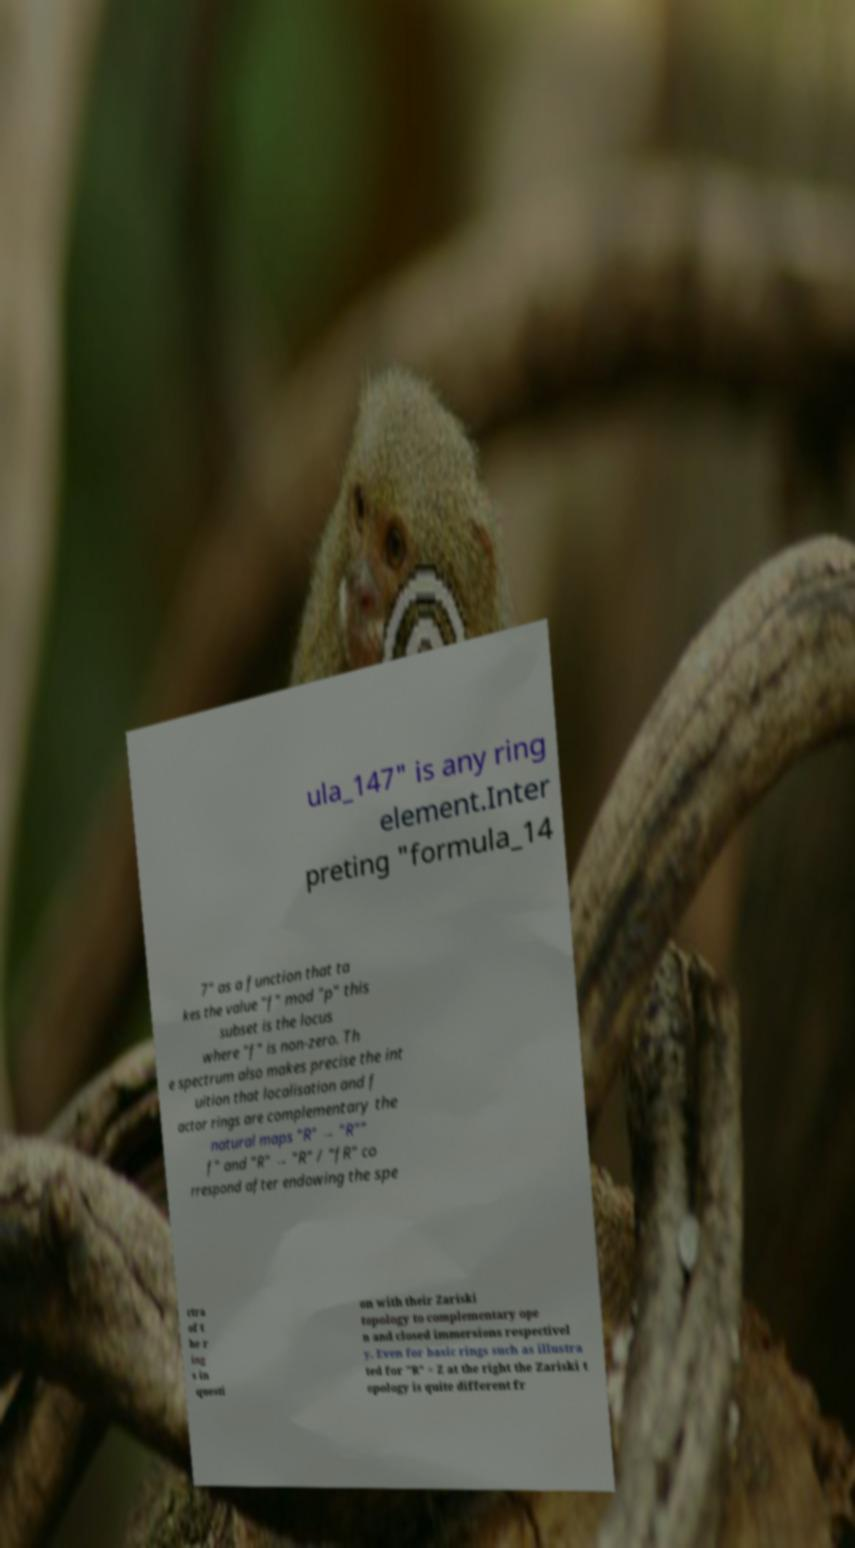Can you read and provide the text displayed in the image?This photo seems to have some interesting text. Can you extract and type it out for me? ula_147" is any ring element.Inter preting "formula_14 7" as a function that ta kes the value "f" mod "p" this subset is the locus where "f" is non-zero. Th e spectrum also makes precise the int uition that localisation and f actor rings are complementary the natural maps "R" → "R"" f" and "R" → "R" / "fR" co rrespond after endowing the spe ctra of t he r ing s in questi on with their Zariski topology to complementary ope n and closed immersions respectivel y. Even for basic rings such as illustra ted for "R" = Z at the right the Zariski t opology is quite different fr 